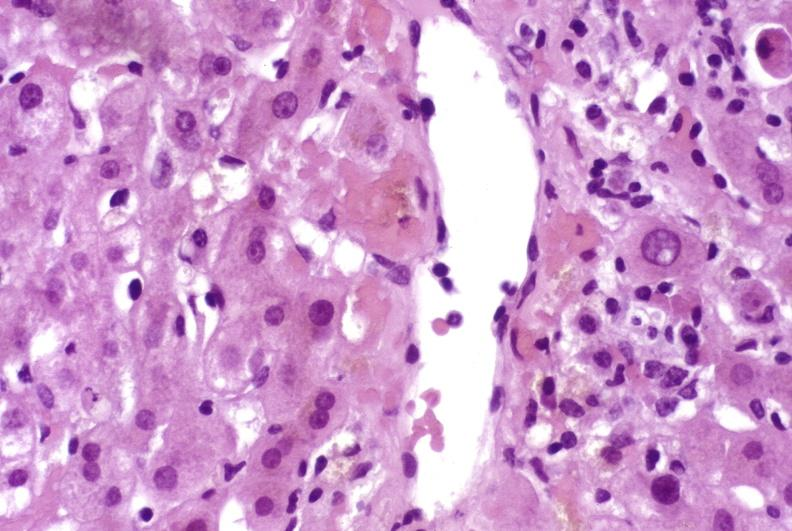does adenocarcinoma show mild acute rejection?
Answer the question using a single word or phrase. No 